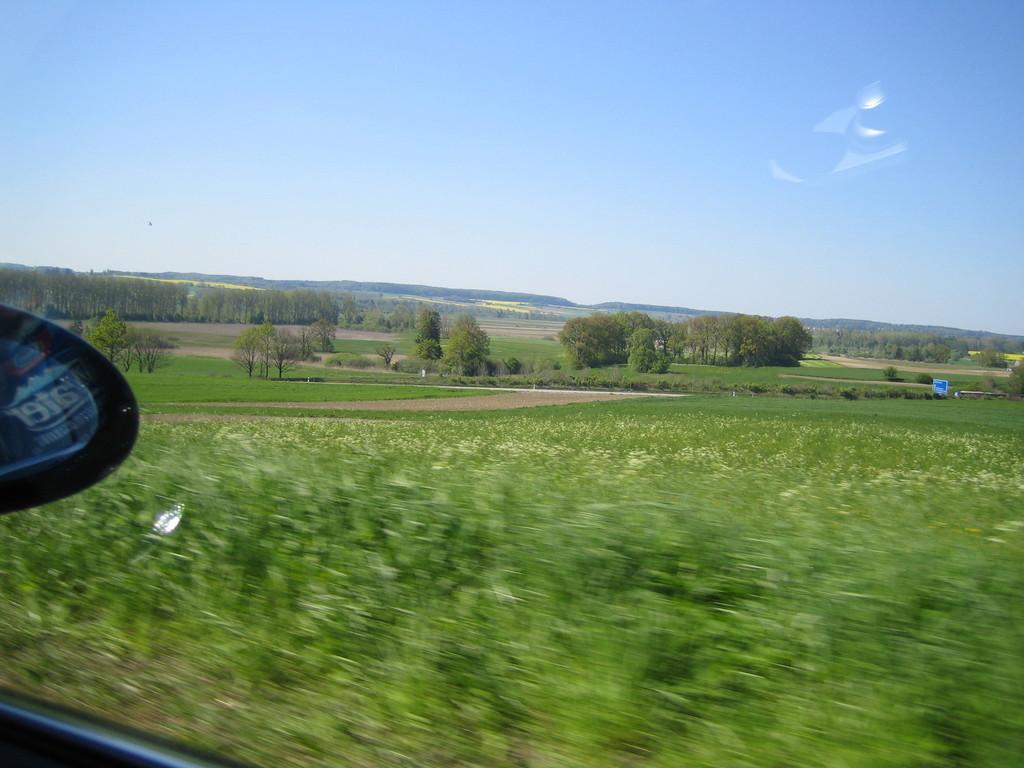Please provide a concise description of this image. It's a glass of a vehicle, outside this there are trees. At the top it's a sky. 